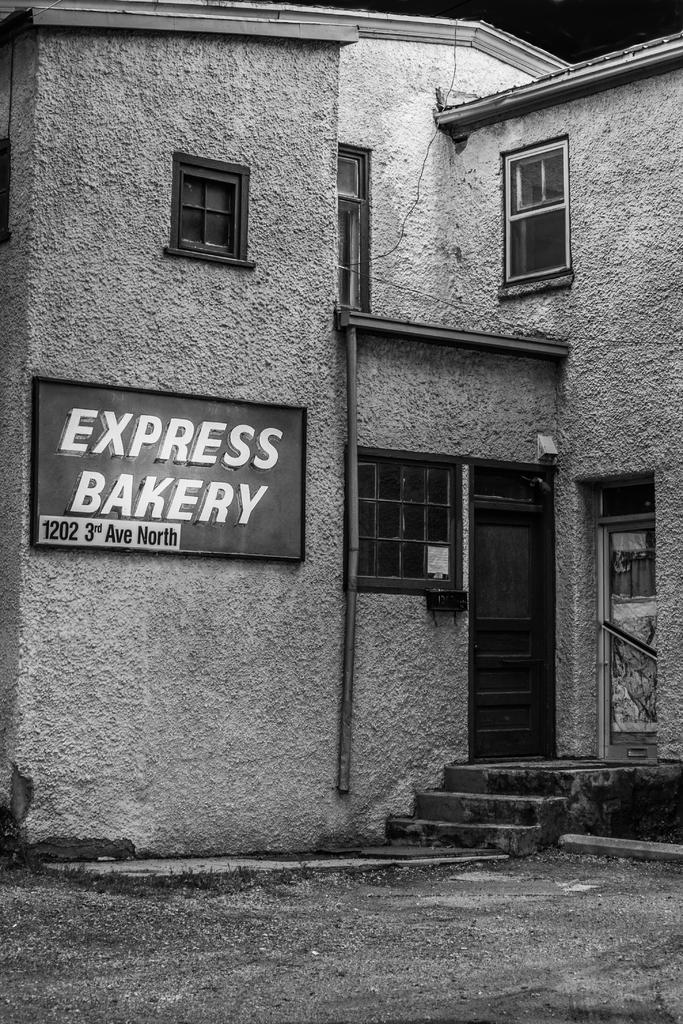Can you describe this image briefly? This is a black and white image of a house where there is a name board attached to it. 